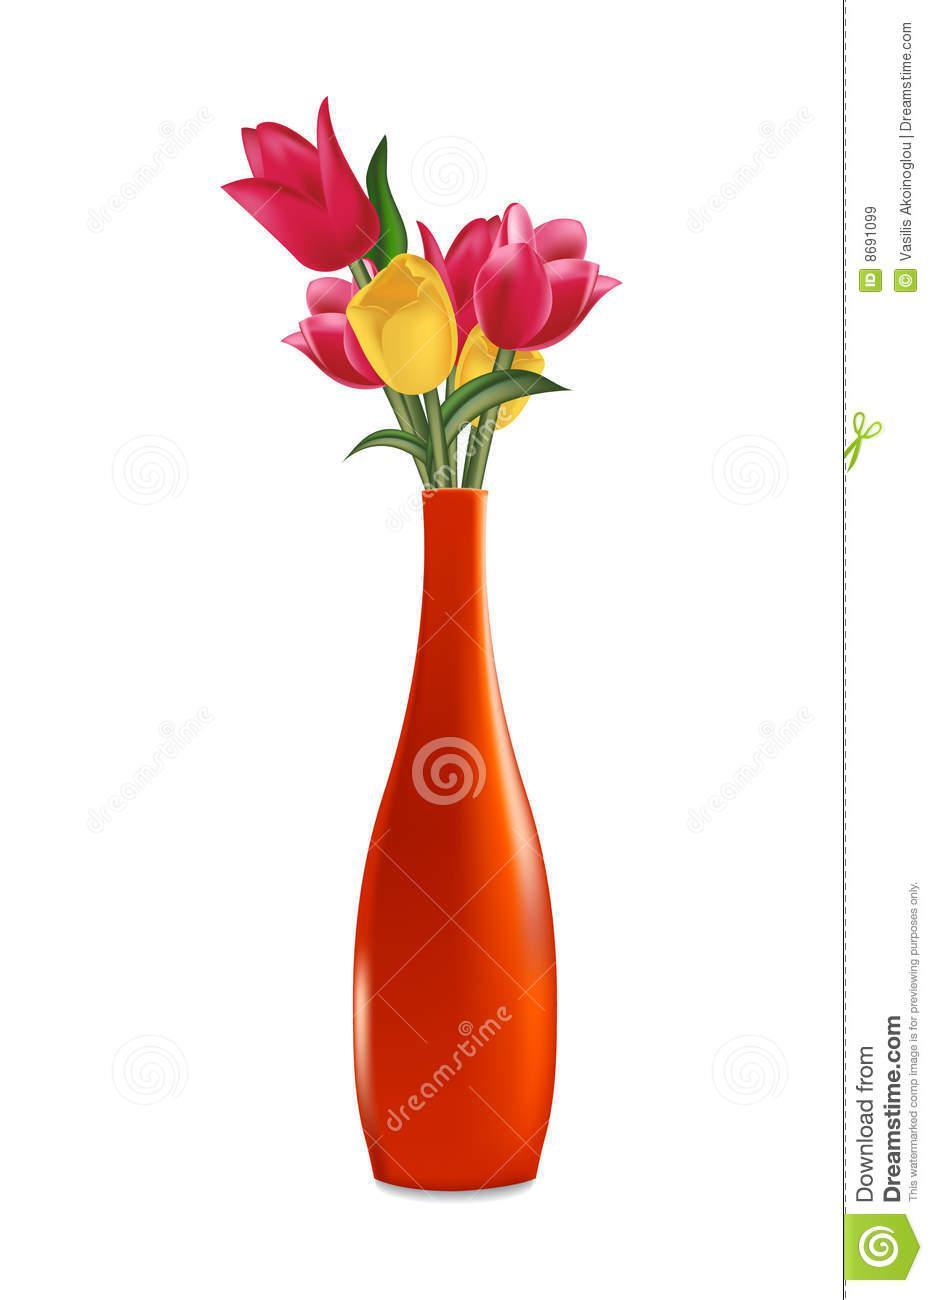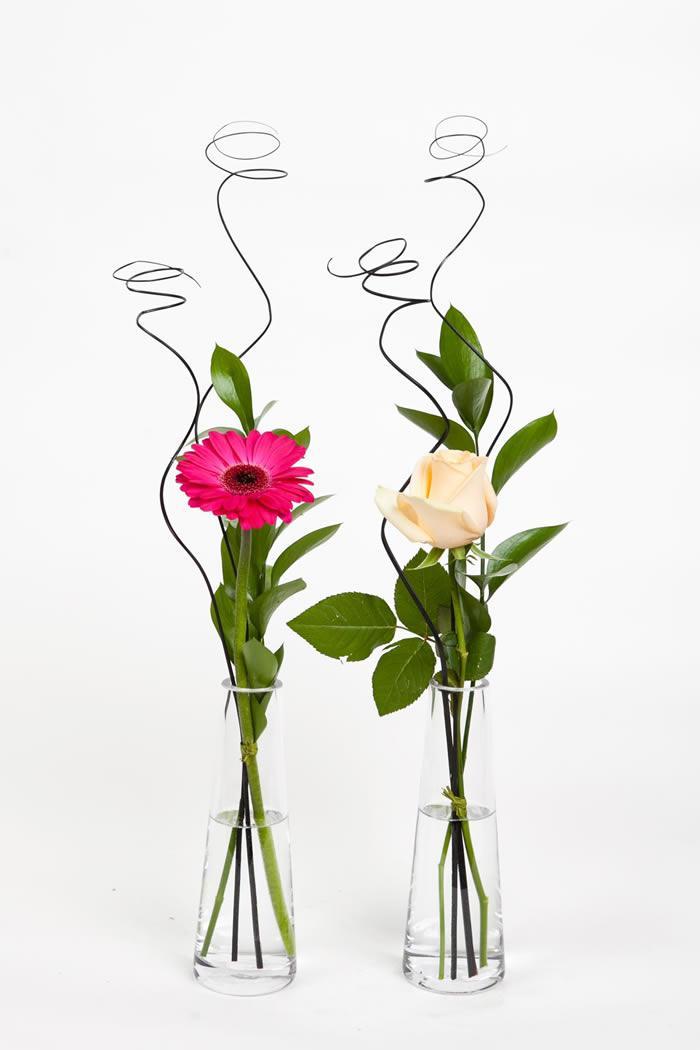The first image is the image on the left, the second image is the image on the right. For the images shown, is this caption "There are exactly two clear glass vases." true? Answer yes or no. Yes. The first image is the image on the left, the second image is the image on the right. Given the left and right images, does the statement "There are 2 vases." hold true? Answer yes or no. No. 